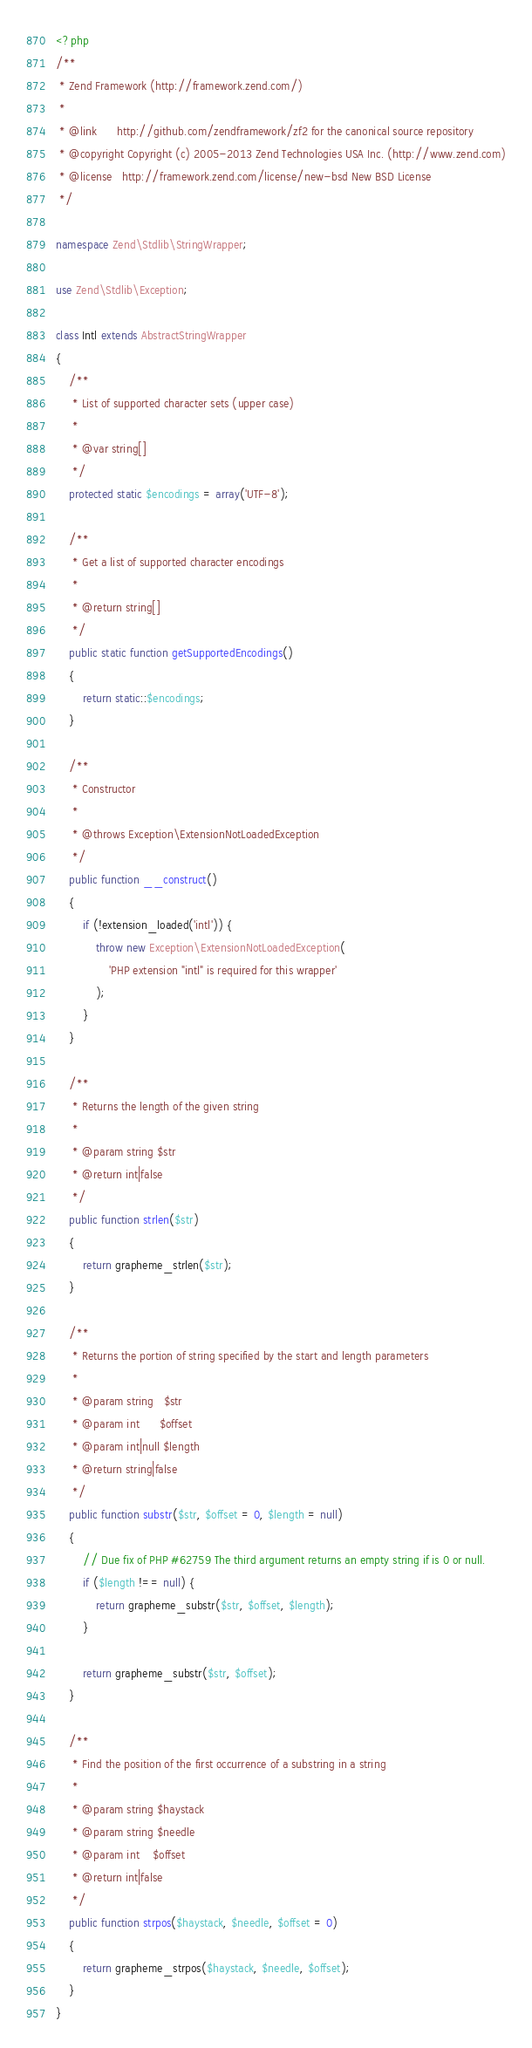Convert code to text. <code><loc_0><loc_0><loc_500><loc_500><_PHP_><?php
/**
 * Zend Framework (http://framework.zend.com/)
 *
 * @link      http://github.com/zendframework/zf2 for the canonical source repository
 * @copyright Copyright (c) 2005-2013 Zend Technologies USA Inc. (http://www.zend.com)
 * @license   http://framework.zend.com/license/new-bsd New BSD License
 */

namespace Zend\Stdlib\StringWrapper;

use Zend\Stdlib\Exception;

class Intl extends AbstractStringWrapper
{
    /**
     * List of supported character sets (upper case)
     *
     * @var string[]
     */
    protected static $encodings = array('UTF-8');

    /**
     * Get a list of supported character encodings
     *
     * @return string[]
     */
    public static function getSupportedEncodings()
    {
        return static::$encodings;
    }

    /**
     * Constructor
     *
     * @throws Exception\ExtensionNotLoadedException
     */
    public function __construct()
    {
        if (!extension_loaded('intl')) {
            throw new Exception\ExtensionNotLoadedException(
                'PHP extension "intl" is required for this wrapper'
            );
        }
    }

    /**
     * Returns the length of the given string
     *
     * @param string $str
     * @return int|false
     */
    public function strlen($str)
    {
        return grapheme_strlen($str);
    }

    /**
     * Returns the portion of string specified by the start and length parameters
     *
     * @param string   $str
     * @param int      $offset
     * @param int|null $length
     * @return string|false
     */
    public function substr($str, $offset = 0, $length = null)
    {
        // Due fix of PHP #62759 The third argument returns an empty string if is 0 or null.
        if ($length !== null) {
            return grapheme_substr($str, $offset, $length);
        }

        return grapheme_substr($str, $offset);
    }

    /**
     * Find the position of the first occurrence of a substring in a string
     *
     * @param string $haystack
     * @param string $needle
     * @param int    $offset
     * @return int|false
     */
    public function strpos($haystack, $needle, $offset = 0)
    {
        return grapheme_strpos($haystack, $needle, $offset);
    }
}
</code> 